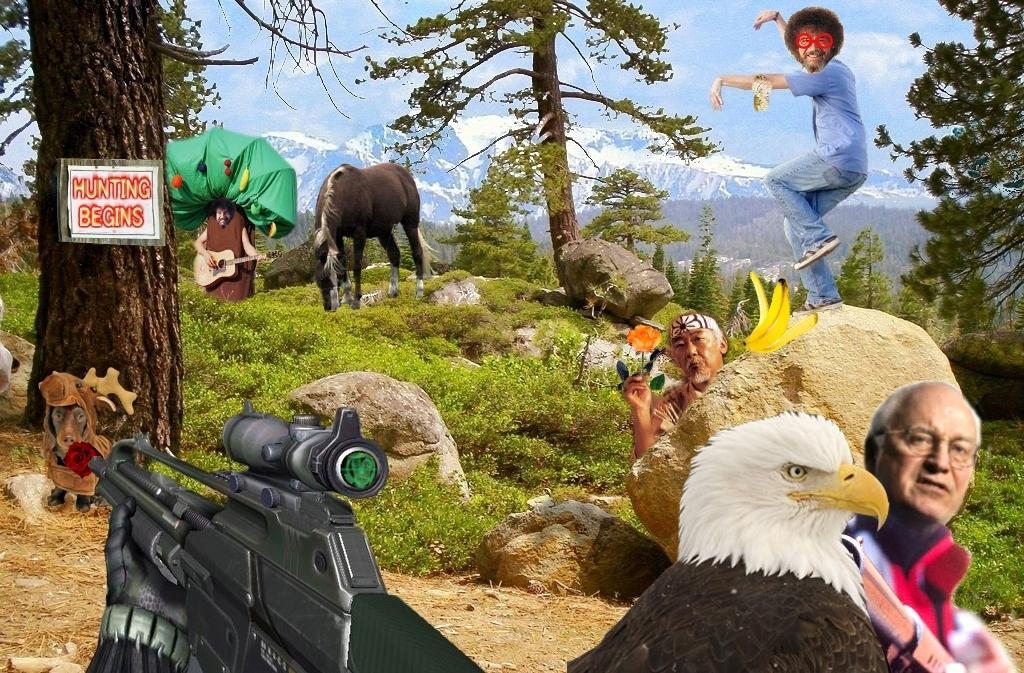Can you describe this image briefly? This image is a depiction. At the bottom of the image we can see eagle, gun and person. On the right side of the image we can see person standing on the stone and person holding a flower. On the left side of the image we can see tree, horses and person holding guitar. In the background we can see mountains, trees, sky and clouds. 